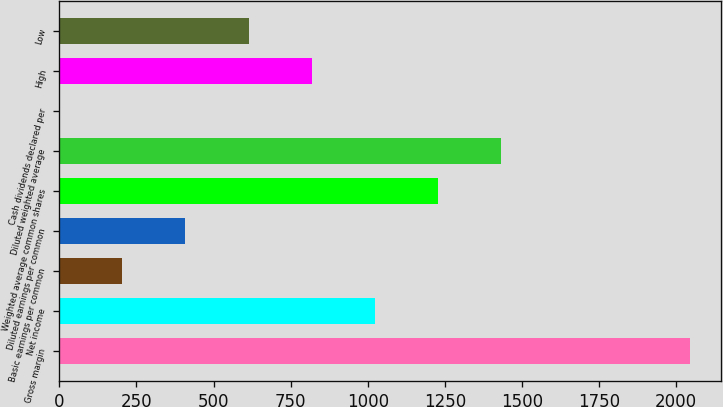<chart> <loc_0><loc_0><loc_500><loc_500><bar_chart><fcel>Gross margin<fcel>Net income<fcel>Basic earnings per common<fcel>Diluted earnings per common<fcel>Weighted average common shares<fcel>Diluted weighted average<fcel>Cash dividends declared per<fcel>High<fcel>Low<nl><fcel>2043.8<fcel>1022.05<fcel>204.61<fcel>408.97<fcel>1226.4<fcel>1430.76<fcel>0.25<fcel>817.69<fcel>613.33<nl></chart> 